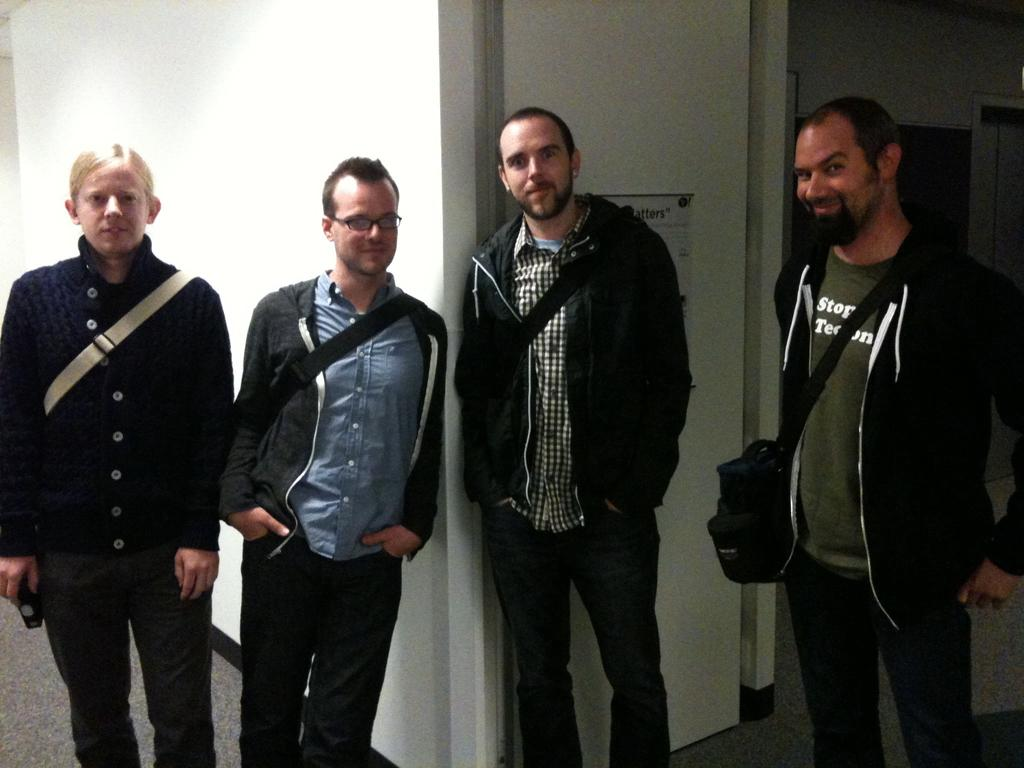How many people are in the image? There are four men in the image. What are the men doing in the image? The men are standing in front and smiling. Can you describe any specific features of one of the men? One of the men is wearing spectacles. What can be seen in the background of the image? There is a white wall in the background of the image. What type of pain can be seen on the faces of the men in the image? There is no indication of pain on the faces of the men in the image; they are all smiling. How many cubs are visible in the image? There are no cubs present in the image. 